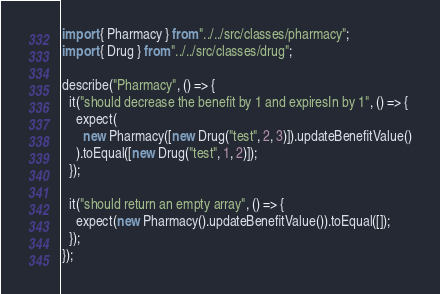<code> <loc_0><loc_0><loc_500><loc_500><_JavaScript_>import { Pharmacy } from "../../src/classes/pharmacy";
import { Drug } from "../../src/classes/drug";

describe("Pharmacy", () => {
  it("should decrease the benefit by 1 and expiresIn by 1", () => {
    expect(
      new Pharmacy([new Drug("test", 2, 3)]).updateBenefitValue()
    ).toEqual([new Drug("test", 1, 2)]);
  });

  it("should return an empty array", () => {
    expect(new Pharmacy().updateBenefitValue()).toEqual([]);
  });
});
</code> 